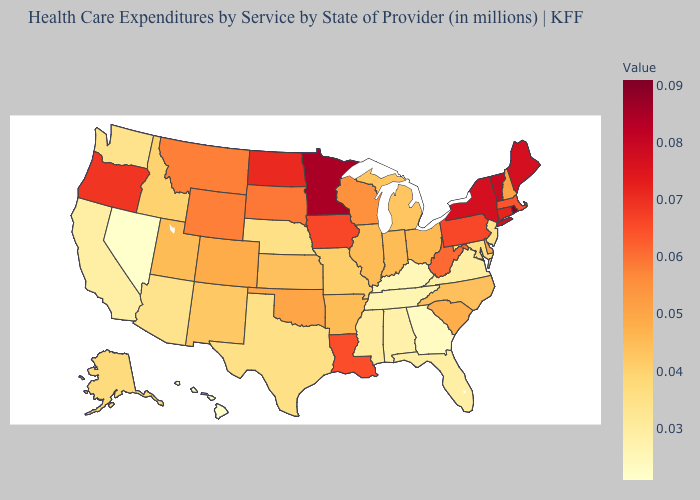Does Maine have the highest value in the Northeast?
Give a very brief answer. No. Among the states that border Rhode Island , which have the lowest value?
Concise answer only. Massachusetts. Does the map have missing data?
Be succinct. No. Does Nevada have the lowest value in the USA?
Concise answer only. Yes. Which states have the lowest value in the West?
Write a very short answer. Hawaii, Nevada. Among the states that border Kentucky , does West Virginia have the highest value?
Answer briefly. Yes. Among the states that border Colorado , which have the lowest value?
Quick response, please. Arizona. 